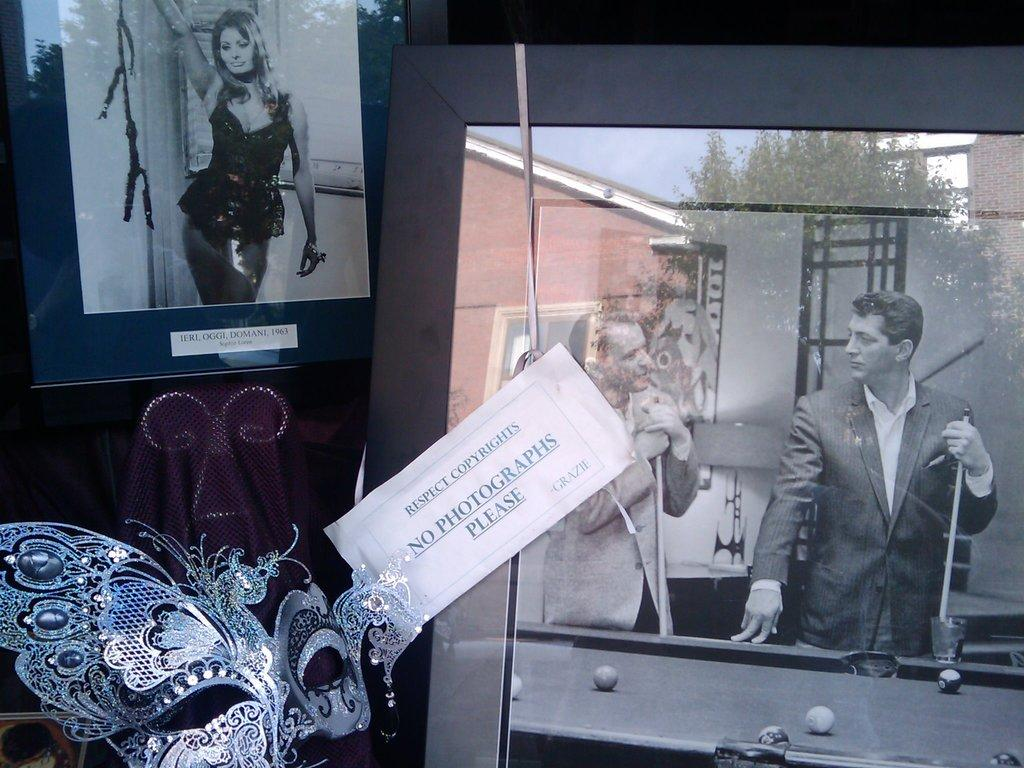What object is located on the right side of the image? There is a mirror on the right side of the image. What activity is the man engaged in near the billiards game table? The man is standing near a billiards game table. What type of clothing is the man wearing? The man is wearing a coat. What can be seen on the left side of the image? There is an image of a woman on the left side of the image. How many cakes are being organized by the man in the image? There is no mention of cakes or any organization activity in the image. 